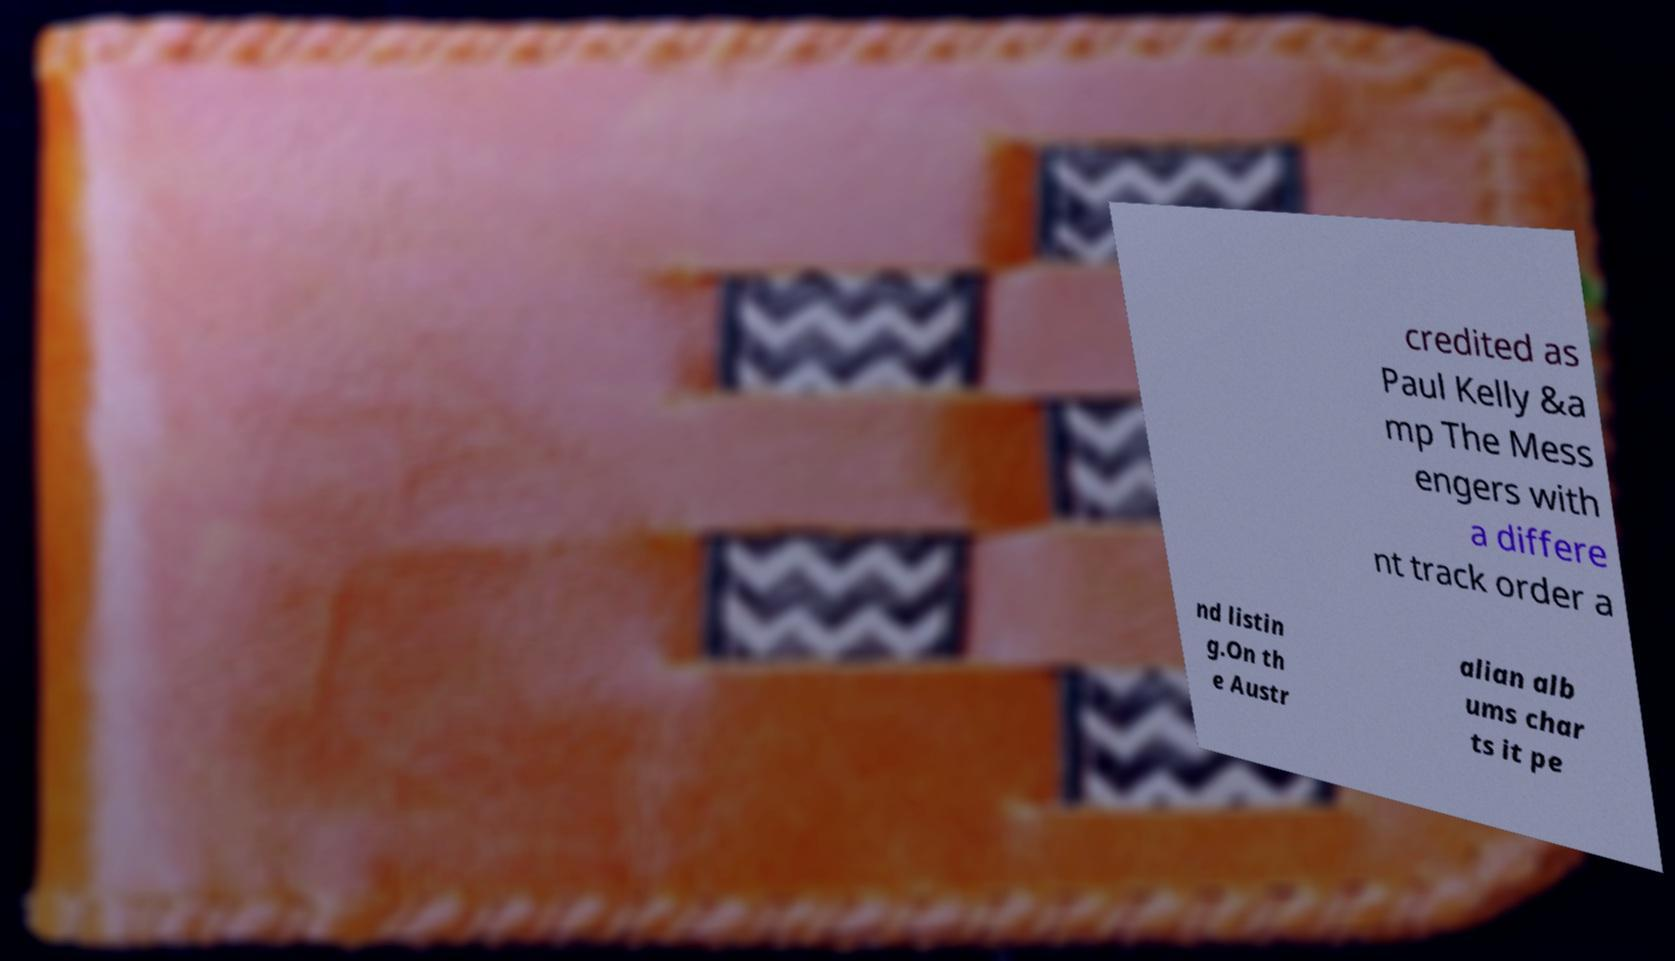Can you read and provide the text displayed in the image?This photo seems to have some interesting text. Can you extract and type it out for me? credited as Paul Kelly &a mp The Mess engers with a differe nt track order a nd listin g.On th e Austr alian alb ums char ts it pe 